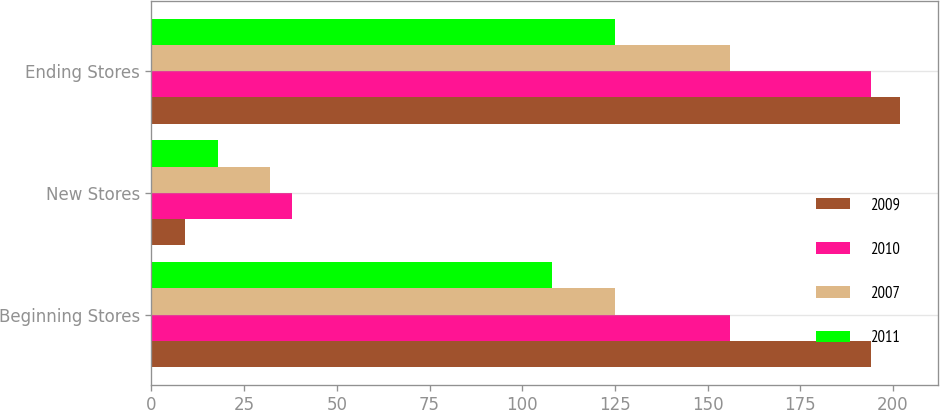<chart> <loc_0><loc_0><loc_500><loc_500><stacked_bar_chart><ecel><fcel>Beginning Stores<fcel>New Stores<fcel>Ending Stores<nl><fcel>2009<fcel>194<fcel>9<fcel>202<nl><fcel>2010<fcel>156<fcel>38<fcel>194<nl><fcel>2007<fcel>125<fcel>32<fcel>156<nl><fcel>2011<fcel>108<fcel>18<fcel>125<nl></chart> 